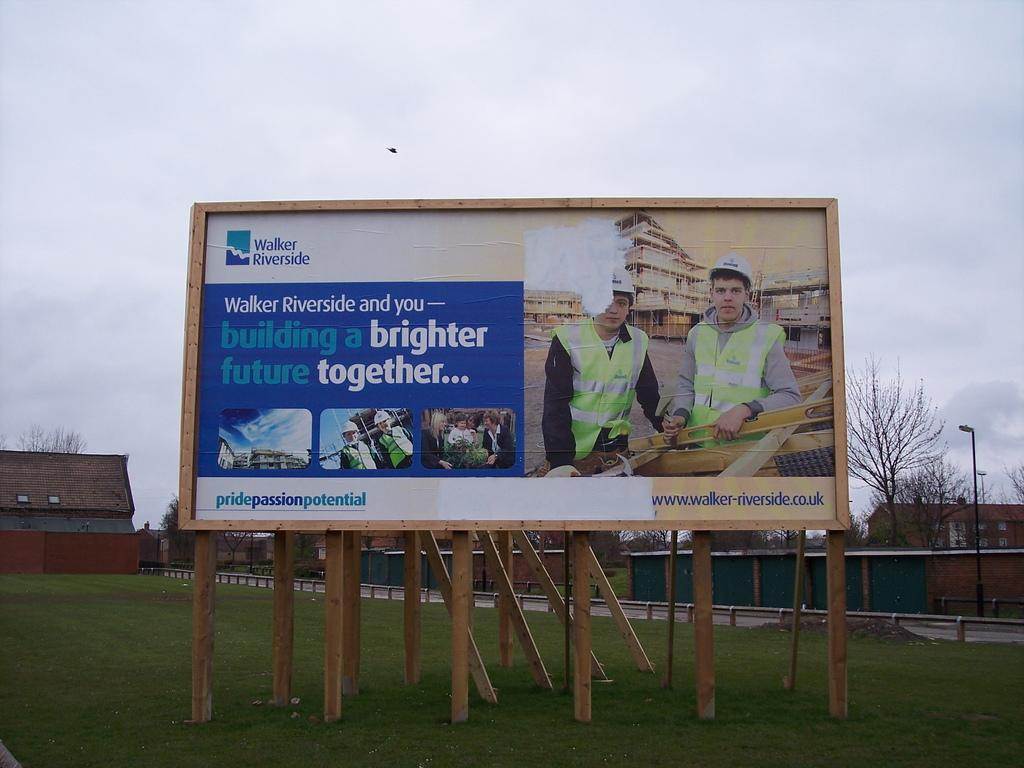<image>
Offer a succinct explanation of the picture presented. A billboard advertises Walker Riverside and shows to workers on it. 